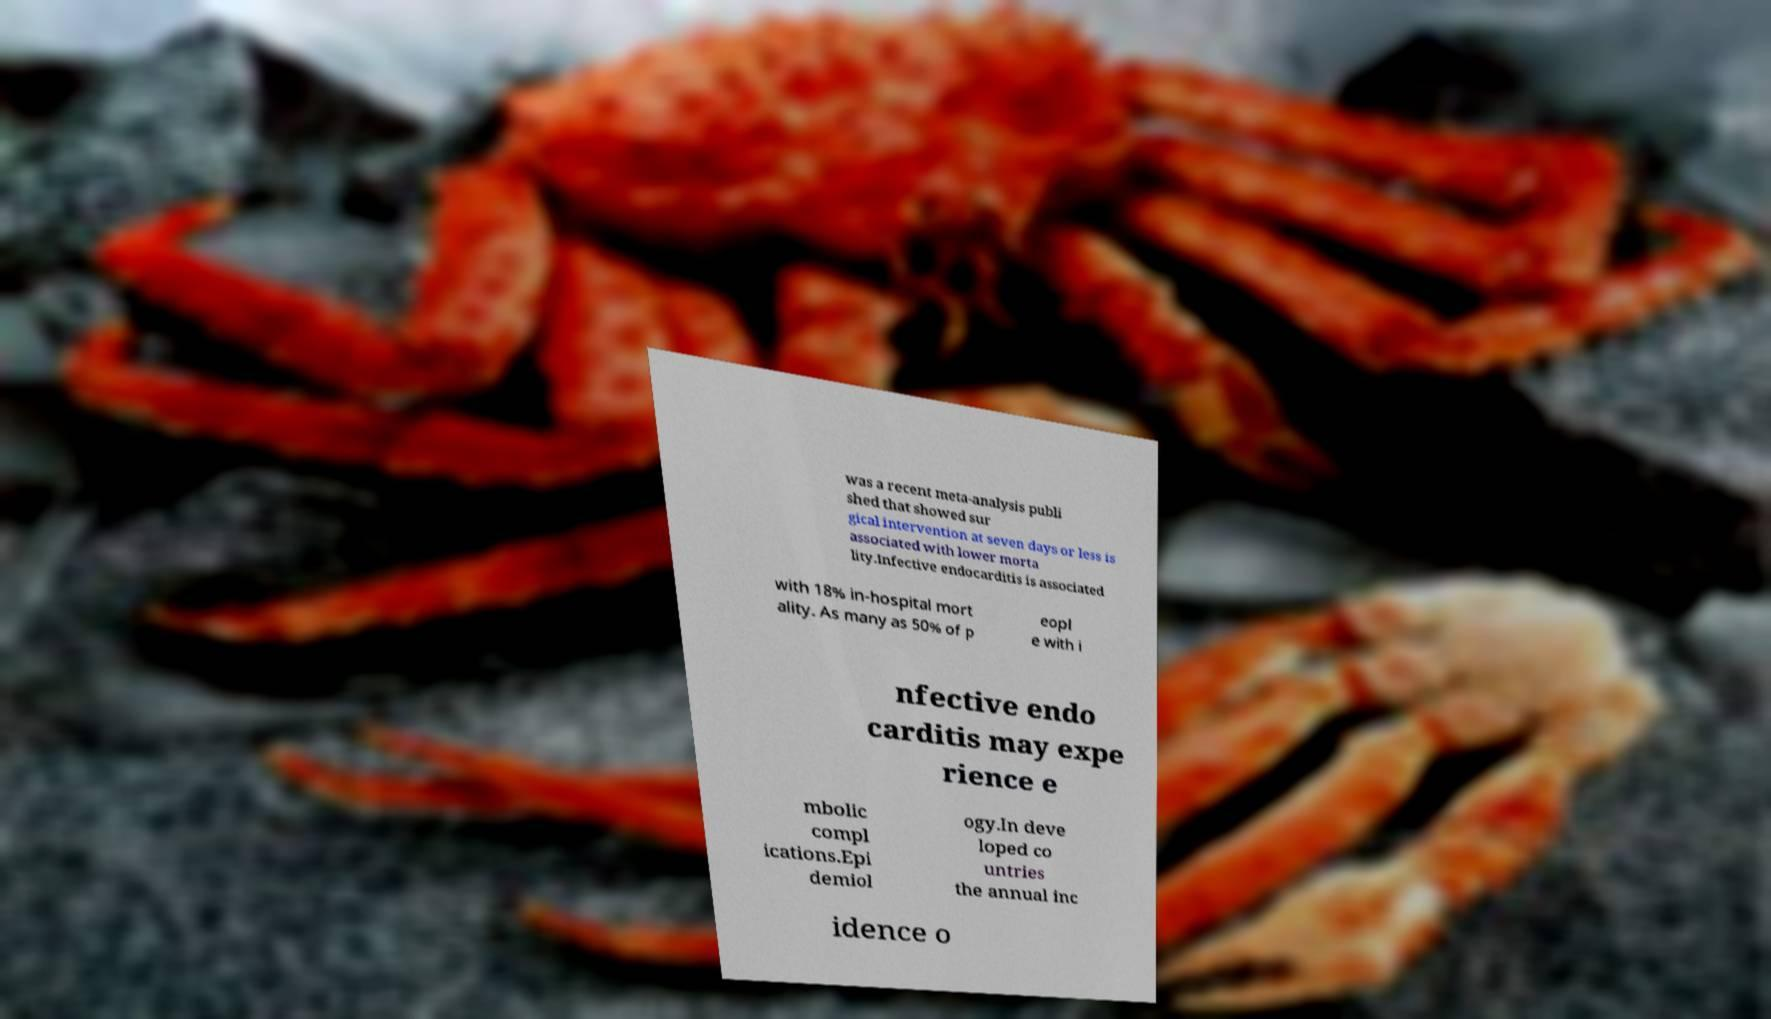Please identify and transcribe the text found in this image. was a recent meta-analysis publi shed that showed sur gical intervention at seven days or less is associated with lower morta lity.Infective endocarditis is associated with 18% in-hospital mort ality. As many as 50% of p eopl e with i nfective endo carditis may expe rience e mbolic compl ications.Epi demiol ogy.In deve loped co untries the annual inc idence o 